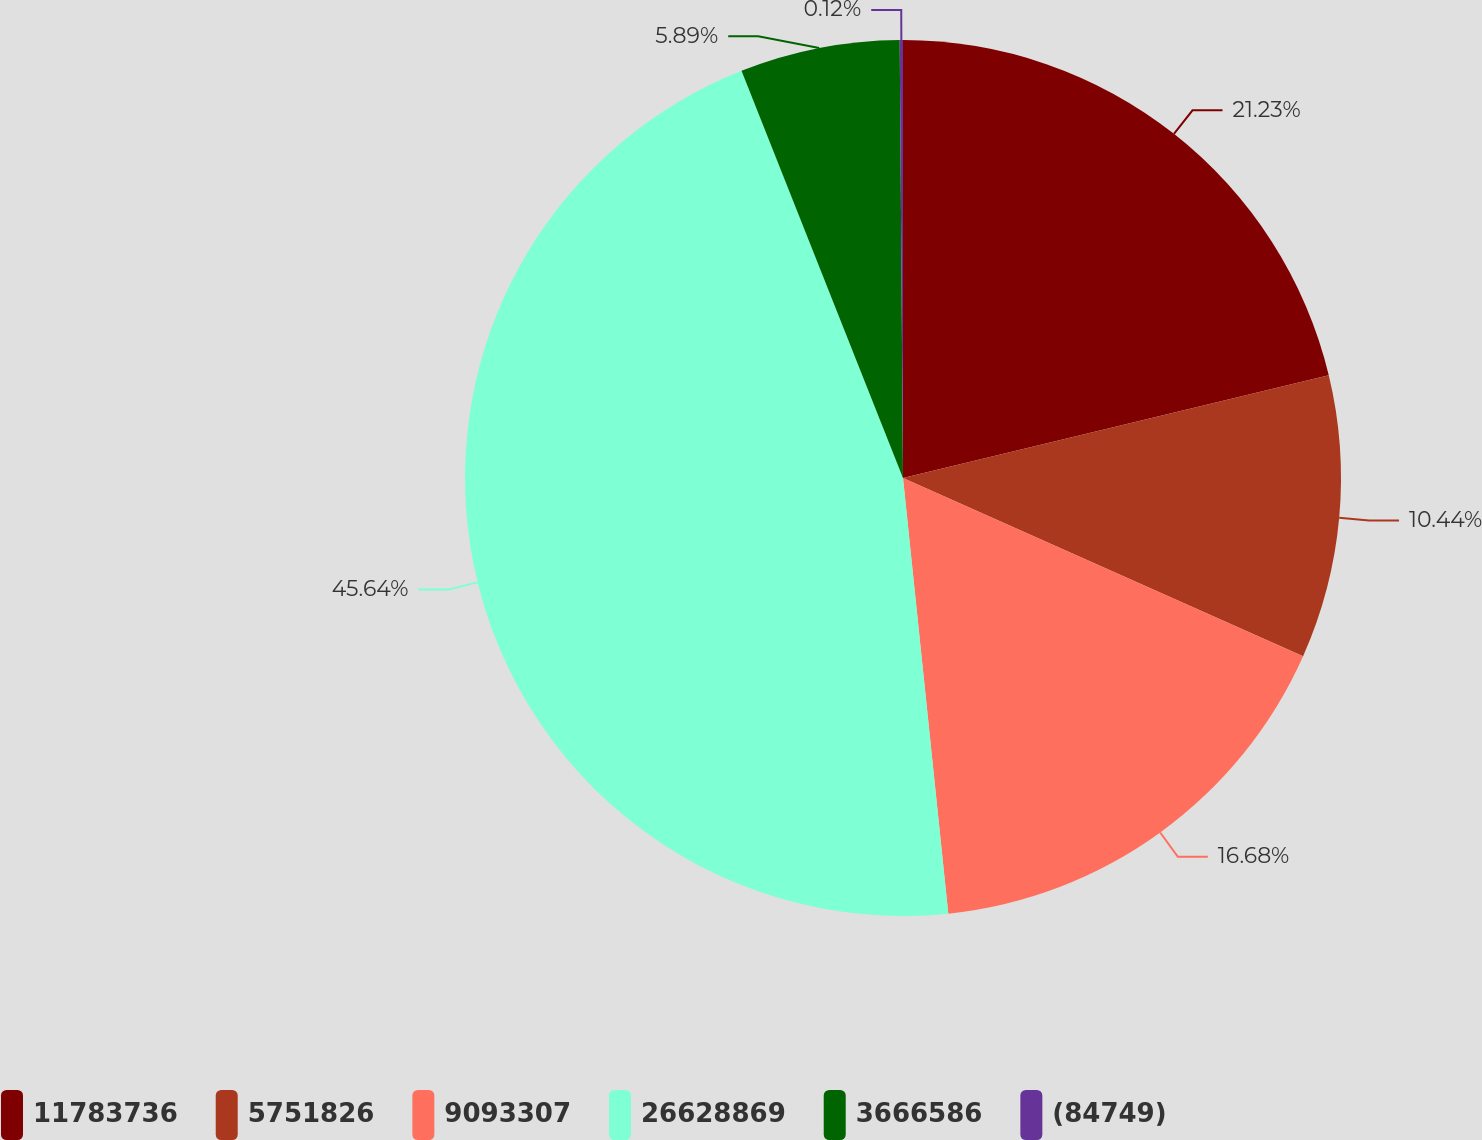Convert chart to OTSL. <chart><loc_0><loc_0><loc_500><loc_500><pie_chart><fcel>11783736<fcel>5751826<fcel>9093307<fcel>26628869<fcel>3666586<fcel>(84749)<nl><fcel>21.23%<fcel>10.44%<fcel>16.68%<fcel>45.64%<fcel>5.89%<fcel>0.12%<nl></chart> 